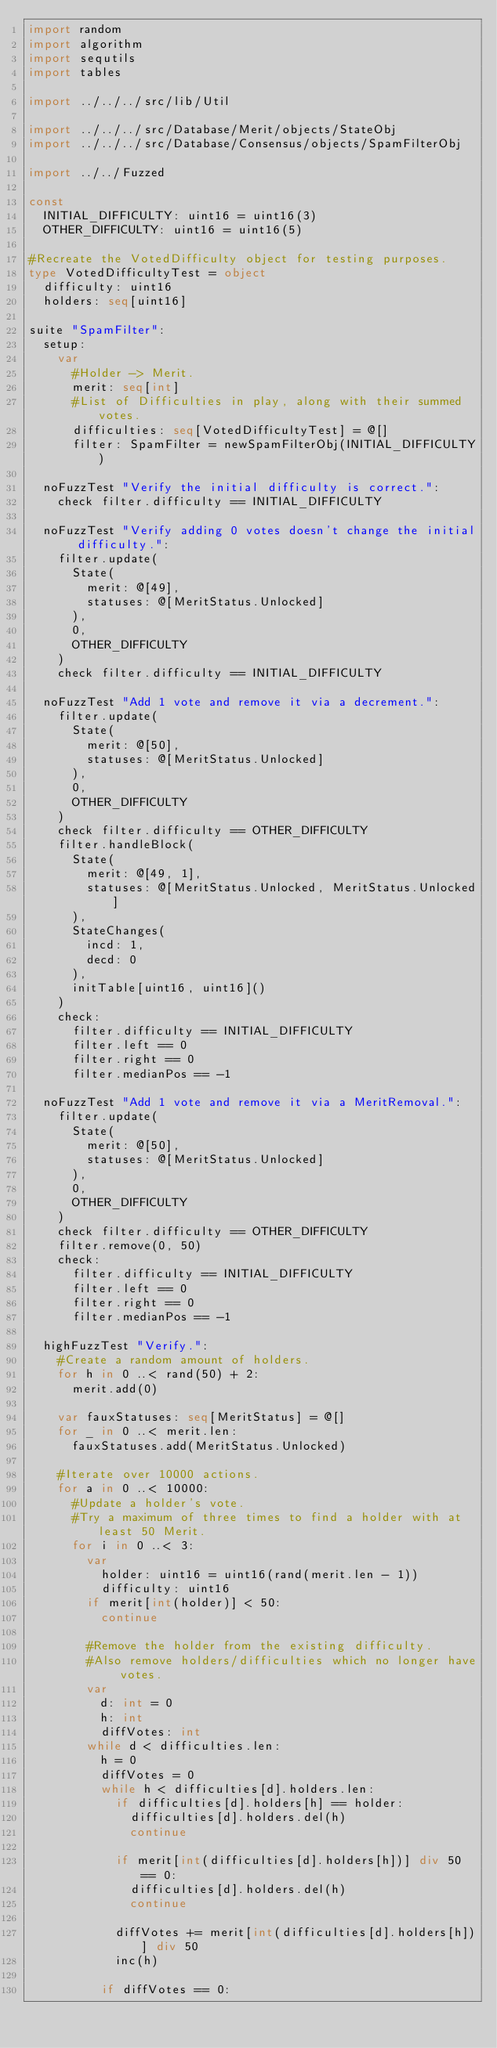Convert code to text. <code><loc_0><loc_0><loc_500><loc_500><_Nim_>import random
import algorithm
import sequtils
import tables

import ../../../src/lib/Util

import ../../../src/Database/Merit/objects/StateObj
import ../../../src/Database/Consensus/objects/SpamFilterObj

import ../../Fuzzed

const
  INITIAL_DIFFICULTY: uint16 = uint16(3)
  OTHER_DIFFICULTY: uint16 = uint16(5)

#Recreate the VotedDifficulty object for testing purposes.
type VotedDifficultyTest = object
  difficulty: uint16
  holders: seq[uint16]

suite "SpamFilter":
  setup:
    var
      #Holder -> Merit.
      merit: seq[int]
      #List of Difficulties in play, along with their summed votes.
      difficulties: seq[VotedDifficultyTest] = @[]
      filter: SpamFilter = newSpamFilterObj(INITIAL_DIFFICULTY)

  noFuzzTest "Verify the initial difficulty is correct.":
    check filter.difficulty == INITIAL_DIFFICULTY

  noFuzzTest "Verify adding 0 votes doesn't change the initial difficulty.":
    filter.update(
      State(
        merit: @[49],
        statuses: @[MeritStatus.Unlocked]
      ),
      0,
      OTHER_DIFFICULTY
    )
    check filter.difficulty == INITIAL_DIFFICULTY

  noFuzzTest "Add 1 vote and remove it via a decrement.":
    filter.update(
      State(
        merit: @[50],
        statuses: @[MeritStatus.Unlocked]
      ),
      0,
      OTHER_DIFFICULTY
    )
    check filter.difficulty == OTHER_DIFFICULTY
    filter.handleBlock(
      State(
        merit: @[49, 1],
        statuses: @[MeritStatus.Unlocked, MeritStatus.Unlocked]
      ),
      StateChanges(
        incd: 1,
        decd: 0
      ),
      initTable[uint16, uint16]()
    )
    check:
      filter.difficulty == INITIAL_DIFFICULTY
      filter.left == 0
      filter.right == 0
      filter.medianPos == -1

  noFuzzTest "Add 1 vote and remove it via a MeritRemoval.":
    filter.update(
      State(
        merit: @[50],
        statuses: @[MeritStatus.Unlocked]
      ),
      0,
      OTHER_DIFFICULTY
    )
    check filter.difficulty == OTHER_DIFFICULTY
    filter.remove(0, 50)
    check:
      filter.difficulty == INITIAL_DIFFICULTY
      filter.left == 0
      filter.right == 0
      filter.medianPos == -1

  highFuzzTest "Verify.":
    #Create a random amount of holders.
    for h in 0 ..< rand(50) + 2:
      merit.add(0)

    var fauxStatuses: seq[MeritStatus] = @[]
    for _ in 0 ..< merit.len:
      fauxStatuses.add(MeritStatus.Unlocked)

    #Iterate over 10000 actions.
    for a in 0 ..< 10000:
      #Update a holder's vote.
      #Try a maximum of three times to find a holder with at least 50 Merit.
      for i in 0 ..< 3:
        var
          holder: uint16 = uint16(rand(merit.len - 1))
          difficulty: uint16
        if merit[int(holder)] < 50:
          continue

        #Remove the holder from the existing difficulty.
        #Also remove holders/difficulties which no longer have votes.
        var
          d: int = 0
          h: int
          diffVotes: int
        while d < difficulties.len:
          h = 0
          diffVotes = 0
          while h < difficulties[d].holders.len:
            if difficulties[d].holders[h] == holder:
              difficulties[d].holders.del(h)
              continue

            if merit[int(difficulties[d].holders[h])] div 50 == 0:
              difficulties[d].holders.del(h)
              continue

            diffVotes += merit[int(difficulties[d].holders[h])] div 50
            inc(h)

          if diffVotes == 0:</code> 